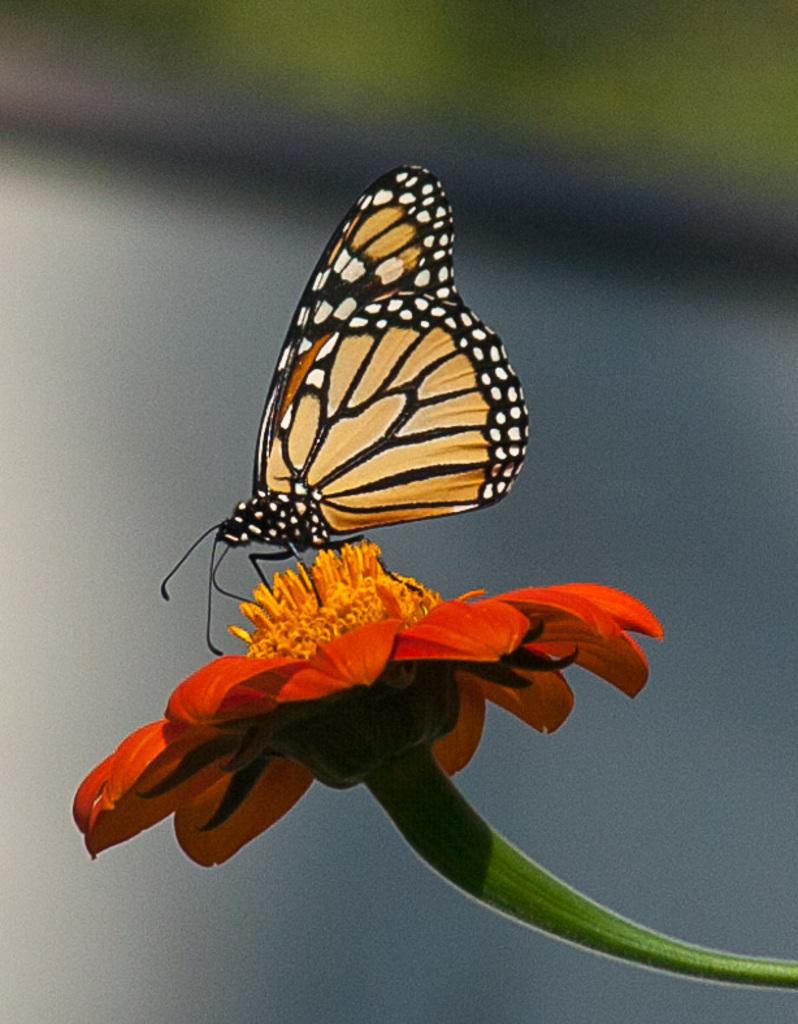What is the main subject of the image? The main subject of the image is a butterfly. Where is the butterfly located in the image? The butterfly is on a flower. Can you describe the background of the image? The background of the image is blurred. What type of crate is visible in the image? There is no crate present in the image. Is there a door in the image? There is no door present in the image. What is the plot of the story being depicted in the image? The image does not depict a story, so there is no plot to describe. 